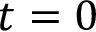<formula> <loc_0><loc_0><loc_500><loc_500>t = 0</formula> 